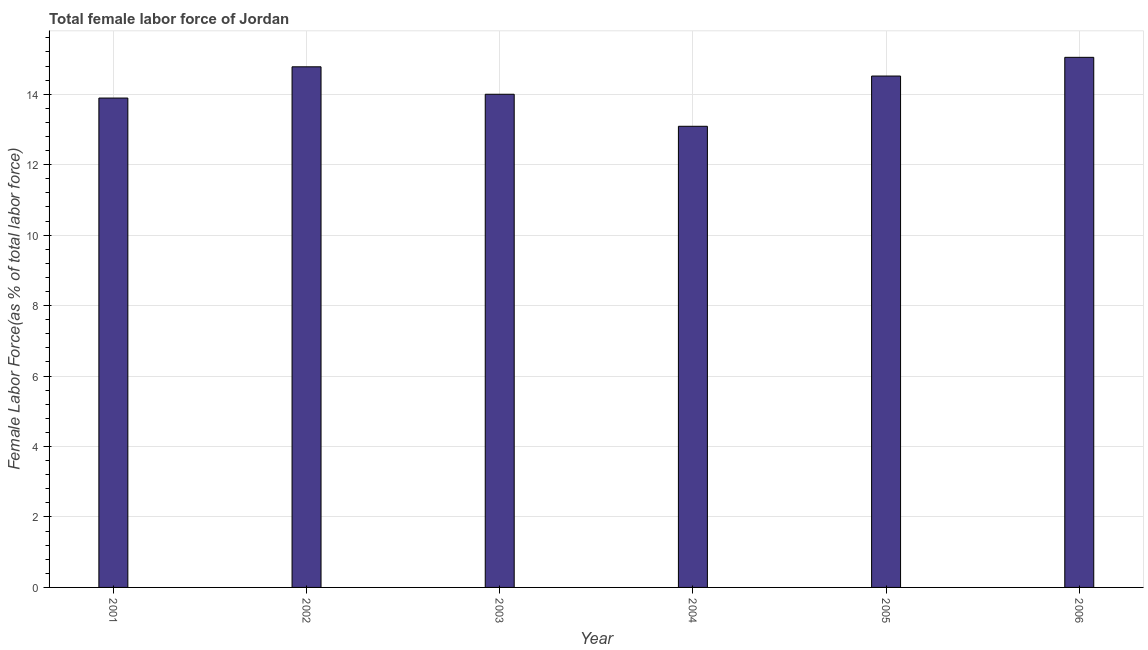Does the graph contain any zero values?
Give a very brief answer. No. Does the graph contain grids?
Make the answer very short. Yes. What is the title of the graph?
Provide a succinct answer. Total female labor force of Jordan. What is the label or title of the Y-axis?
Make the answer very short. Female Labor Force(as % of total labor force). What is the total female labor force in 2003?
Make the answer very short. 14. Across all years, what is the maximum total female labor force?
Offer a very short reply. 15.05. Across all years, what is the minimum total female labor force?
Provide a short and direct response. 13.09. In which year was the total female labor force maximum?
Give a very brief answer. 2006. In which year was the total female labor force minimum?
Provide a short and direct response. 2004. What is the sum of the total female labor force?
Keep it short and to the point. 85.32. What is the difference between the total female labor force in 2004 and 2006?
Keep it short and to the point. -1.96. What is the average total female labor force per year?
Provide a short and direct response. 14.22. What is the median total female labor force?
Provide a short and direct response. 14.26. What is the ratio of the total female labor force in 2001 to that in 2004?
Provide a succinct answer. 1.06. What is the difference between the highest and the second highest total female labor force?
Your response must be concise. 0.27. What is the difference between the highest and the lowest total female labor force?
Your response must be concise. 1.96. In how many years, is the total female labor force greater than the average total female labor force taken over all years?
Offer a terse response. 3. Are the values on the major ticks of Y-axis written in scientific E-notation?
Your answer should be compact. No. What is the Female Labor Force(as % of total labor force) in 2001?
Offer a terse response. 13.89. What is the Female Labor Force(as % of total labor force) of 2002?
Give a very brief answer. 14.78. What is the Female Labor Force(as % of total labor force) of 2003?
Give a very brief answer. 14. What is the Female Labor Force(as % of total labor force) of 2004?
Make the answer very short. 13.09. What is the Female Labor Force(as % of total labor force) of 2005?
Your answer should be compact. 14.52. What is the Female Labor Force(as % of total labor force) of 2006?
Provide a succinct answer. 15.05. What is the difference between the Female Labor Force(as % of total labor force) in 2001 and 2002?
Keep it short and to the point. -0.89. What is the difference between the Female Labor Force(as % of total labor force) in 2001 and 2003?
Offer a very short reply. -0.11. What is the difference between the Female Labor Force(as % of total labor force) in 2001 and 2004?
Provide a succinct answer. 0.8. What is the difference between the Female Labor Force(as % of total labor force) in 2001 and 2005?
Keep it short and to the point. -0.62. What is the difference between the Female Labor Force(as % of total labor force) in 2001 and 2006?
Ensure brevity in your answer.  -1.16. What is the difference between the Female Labor Force(as % of total labor force) in 2002 and 2003?
Give a very brief answer. 0.78. What is the difference between the Female Labor Force(as % of total labor force) in 2002 and 2004?
Your answer should be very brief. 1.69. What is the difference between the Female Labor Force(as % of total labor force) in 2002 and 2005?
Your response must be concise. 0.26. What is the difference between the Female Labor Force(as % of total labor force) in 2002 and 2006?
Make the answer very short. -0.27. What is the difference between the Female Labor Force(as % of total labor force) in 2003 and 2004?
Offer a very short reply. 0.91. What is the difference between the Female Labor Force(as % of total labor force) in 2003 and 2005?
Offer a very short reply. -0.52. What is the difference between the Female Labor Force(as % of total labor force) in 2003 and 2006?
Your response must be concise. -1.05. What is the difference between the Female Labor Force(as % of total labor force) in 2004 and 2005?
Provide a succinct answer. -1.43. What is the difference between the Female Labor Force(as % of total labor force) in 2004 and 2006?
Give a very brief answer. -1.96. What is the difference between the Female Labor Force(as % of total labor force) in 2005 and 2006?
Provide a short and direct response. -0.53. What is the ratio of the Female Labor Force(as % of total labor force) in 2001 to that in 2004?
Keep it short and to the point. 1.06. What is the ratio of the Female Labor Force(as % of total labor force) in 2001 to that in 2006?
Keep it short and to the point. 0.92. What is the ratio of the Female Labor Force(as % of total labor force) in 2002 to that in 2003?
Offer a very short reply. 1.06. What is the ratio of the Female Labor Force(as % of total labor force) in 2002 to that in 2004?
Your response must be concise. 1.13. What is the ratio of the Female Labor Force(as % of total labor force) in 2002 to that in 2005?
Ensure brevity in your answer.  1.02. What is the ratio of the Female Labor Force(as % of total labor force) in 2002 to that in 2006?
Your answer should be very brief. 0.98. What is the ratio of the Female Labor Force(as % of total labor force) in 2003 to that in 2004?
Your response must be concise. 1.07. What is the ratio of the Female Labor Force(as % of total labor force) in 2003 to that in 2005?
Make the answer very short. 0.96. What is the ratio of the Female Labor Force(as % of total labor force) in 2004 to that in 2005?
Give a very brief answer. 0.9. What is the ratio of the Female Labor Force(as % of total labor force) in 2004 to that in 2006?
Provide a short and direct response. 0.87. What is the ratio of the Female Labor Force(as % of total labor force) in 2005 to that in 2006?
Offer a terse response. 0.96. 